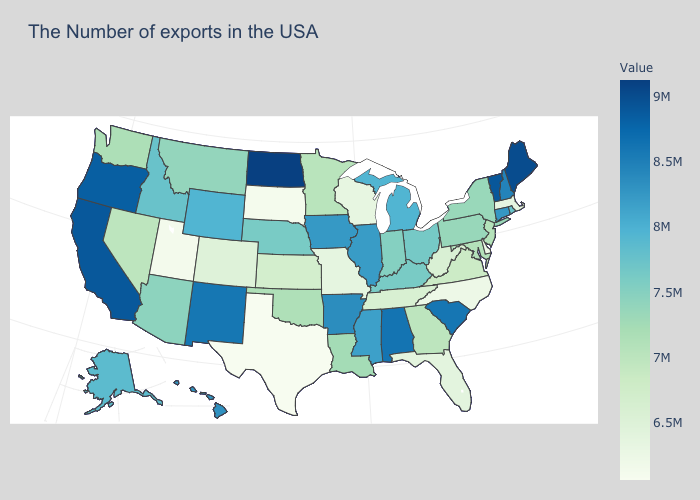Does Massachusetts have the lowest value in the Northeast?
Answer briefly. Yes. Does the map have missing data?
Give a very brief answer. No. Among the states that border New Hampshire , does Maine have the highest value?
Concise answer only. Yes. Does Oregon have a lower value than Michigan?
Be succinct. No. Among the states that border Minnesota , does North Dakota have the highest value?
Concise answer only. Yes. Among the states that border New York , which have the lowest value?
Give a very brief answer. Massachusetts. Which states hav the highest value in the West?
Give a very brief answer. California. 